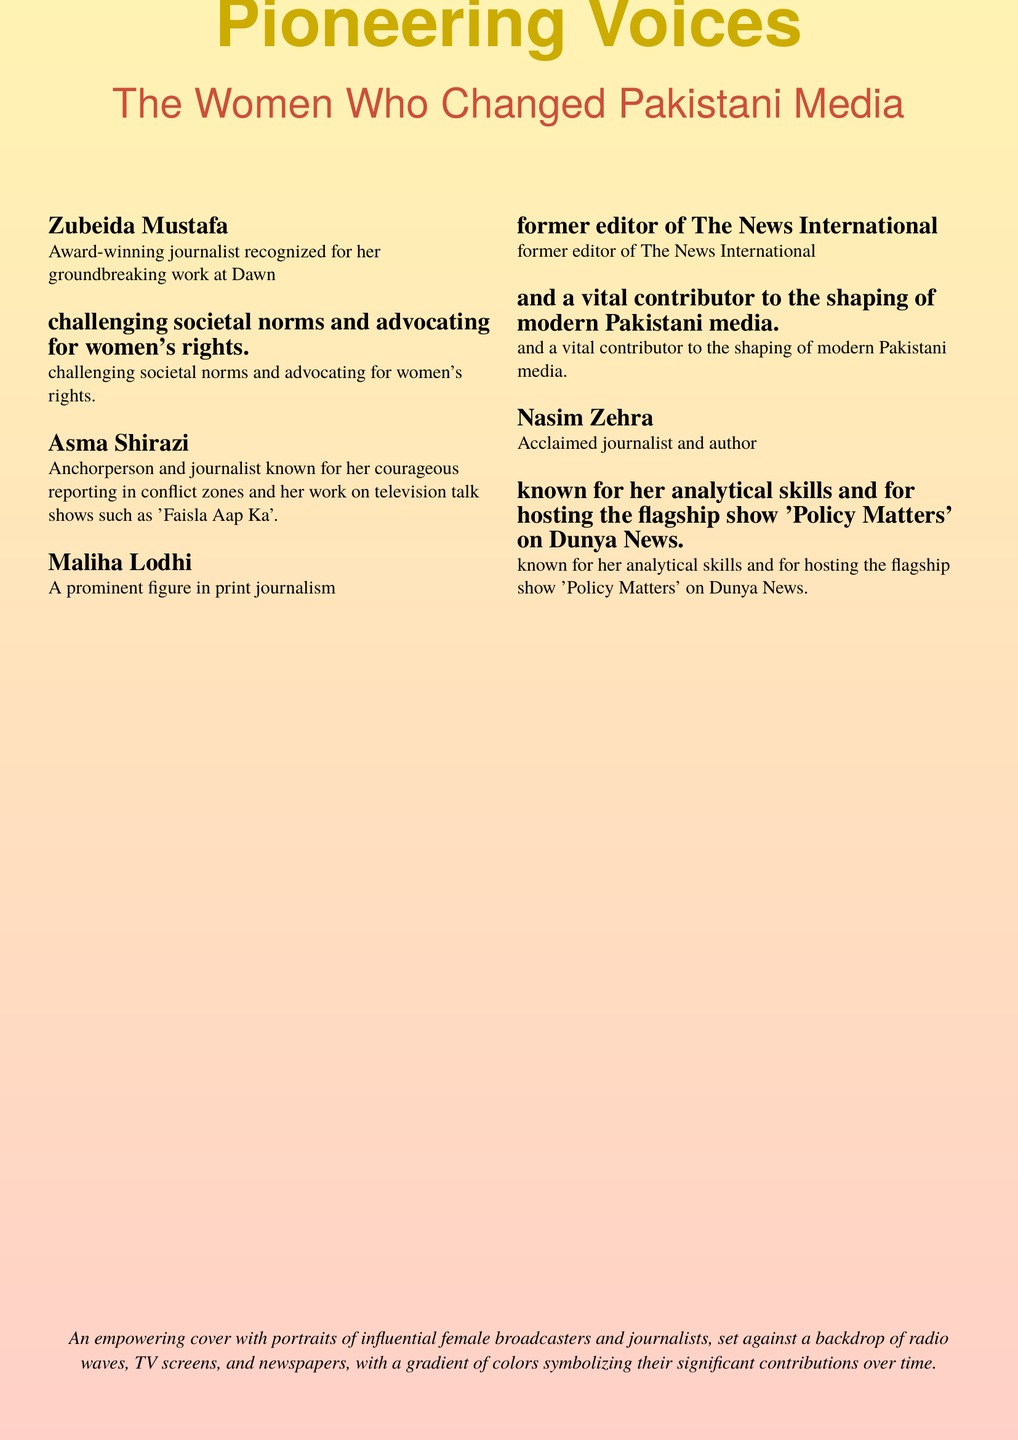What is the title of the book? The title of the book is stated prominently on the cover.
Answer: Pioneering Voices Who is recognized for her groundbreaking work at Dawn? The document mentions Zubeida Mustafa as an award-winning journalist at Dawn.
Answer: Zubeida Mustafa Name one of the prominent figures in print journalism mentioned. The document lists Maliha Lodhi as a prominent figure in print journalism.
Answer: Maliha Lodhi What show is Nasim Zehra known for hosting? The document specifies the flagship show 'Policy Matters' hosted by Nasim Zehra.
Answer: Policy Matters Which journalist is known for reporting in conflict zones? The description indicates that Asma Shirazi is known for her courageous reporting in conflict zones.
Answer: Asma Shirazi How many influential female broadcasters and journalists' portraits are featured? The document lists four influential women, suggesting the focus on their contributions.
Answer: Four What colors are used in the gradient background of the cover? The gradient colors are described in terms of gold and red tones in the cover design.
Answer: Gold and red What type of document is this? The format and content indicate that it is a book cover related to women in media.
Answer: Book cover Which publication is Zubeida Mustafa associated with? The text clearly identifies her association with 'Dawn'.
Answer: Dawn What is the purpose of the cover as described? The cover is designed to symbolize the significant contributions of women in media over time.
Answer: Empowering portrayal 